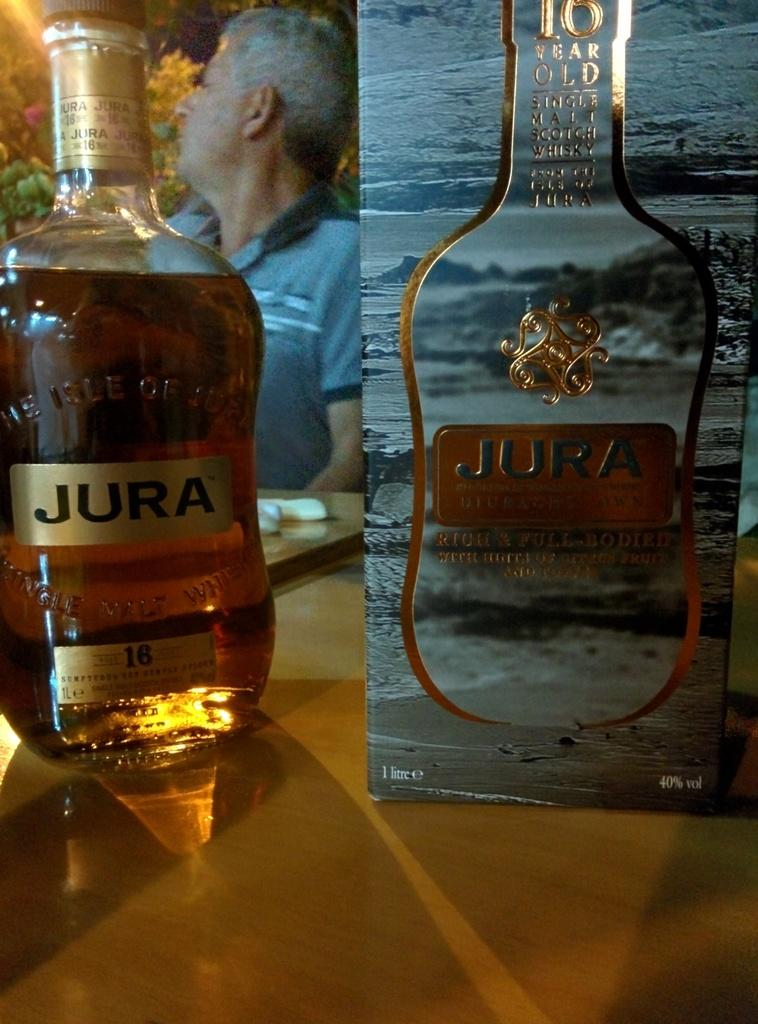Provide a one-sentence caption for the provided image. A bottle and box of Jura sits on a table. 